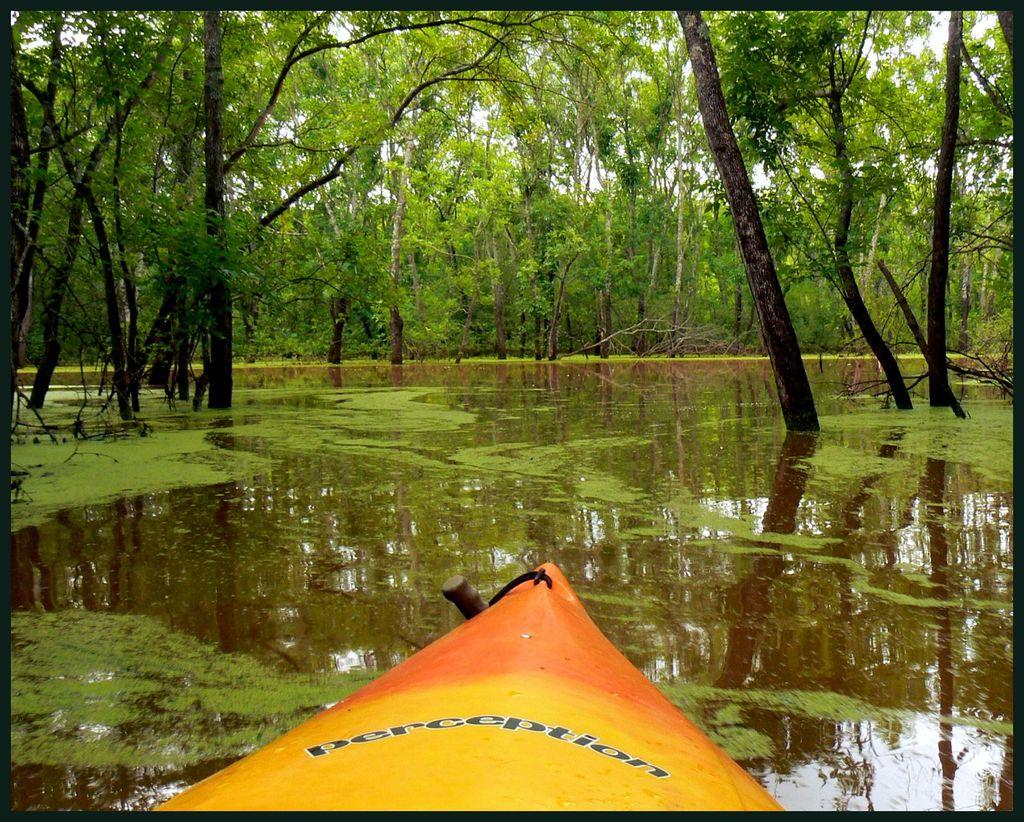What is the main feature in the middle of the image? There is a lake in the middle of the image. What can be seen at the bottom of the image? There is a boat at the bottom of the image. What type of vegetation is at the top of the image? There are trees at the top of the image. Can you tell me how many cats are sitting on the boat in the image? There are no cats present in the image; it features a boat in a lake with trees in the background. What type of memory is stored in the trees at the top of the image? There is no mention of memory in the image; it features a lake, a boat, and trees. 